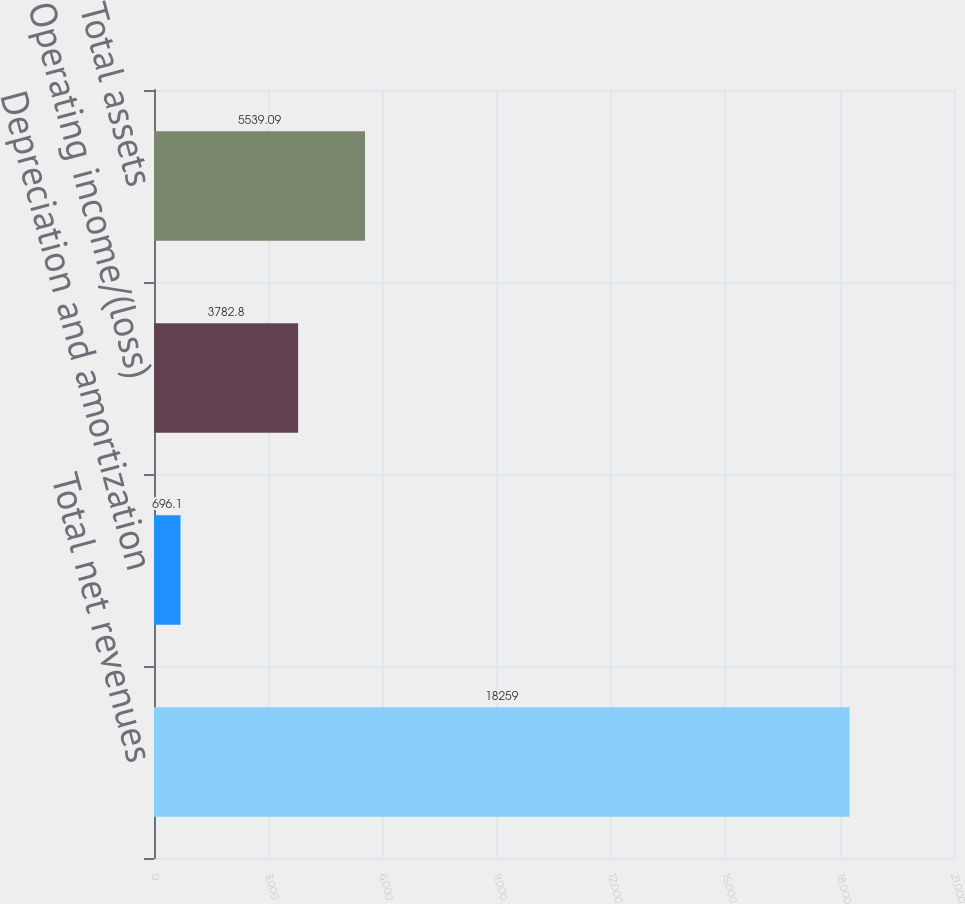Convert chart. <chart><loc_0><loc_0><loc_500><loc_500><bar_chart><fcel>Total net revenues<fcel>Depreciation and amortization<fcel>Operating income/(loss)<fcel>Total assets<nl><fcel>18259<fcel>696.1<fcel>3782.8<fcel>5539.09<nl></chart> 